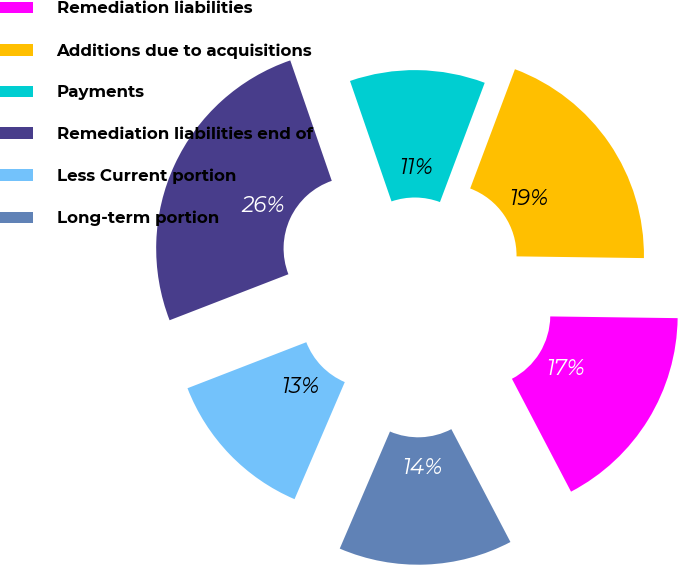Convert chart. <chart><loc_0><loc_0><loc_500><loc_500><pie_chart><fcel>Remediation liabilities<fcel>Additions due to acquisitions<fcel>Payments<fcel>Remediation liabilities end of<fcel>Less Current portion<fcel>Long-term portion<nl><fcel>17.11%<fcel>19.5%<fcel>11.0%<fcel>25.6%<fcel>12.67%<fcel>14.13%<nl></chart> 